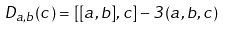Convert formula to latex. <formula><loc_0><loc_0><loc_500><loc_500>D _ { a , b } ( c ) = [ [ a , b ] , c ] - 3 ( a , b , c )</formula> 